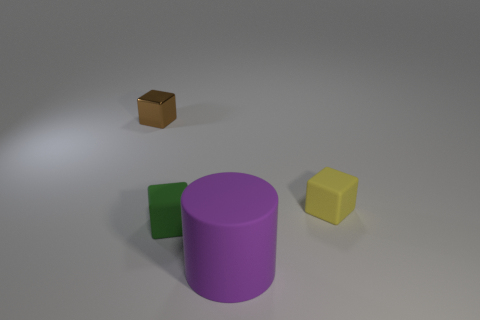Add 1 brown metal blocks. How many objects exist? 5 Subtract all cylinders. How many objects are left? 3 Subtract all small rubber objects. Subtract all yellow matte blocks. How many objects are left? 1 Add 2 purple cylinders. How many purple cylinders are left? 3 Add 1 yellow blocks. How many yellow blocks exist? 2 Subtract 0 gray cylinders. How many objects are left? 4 